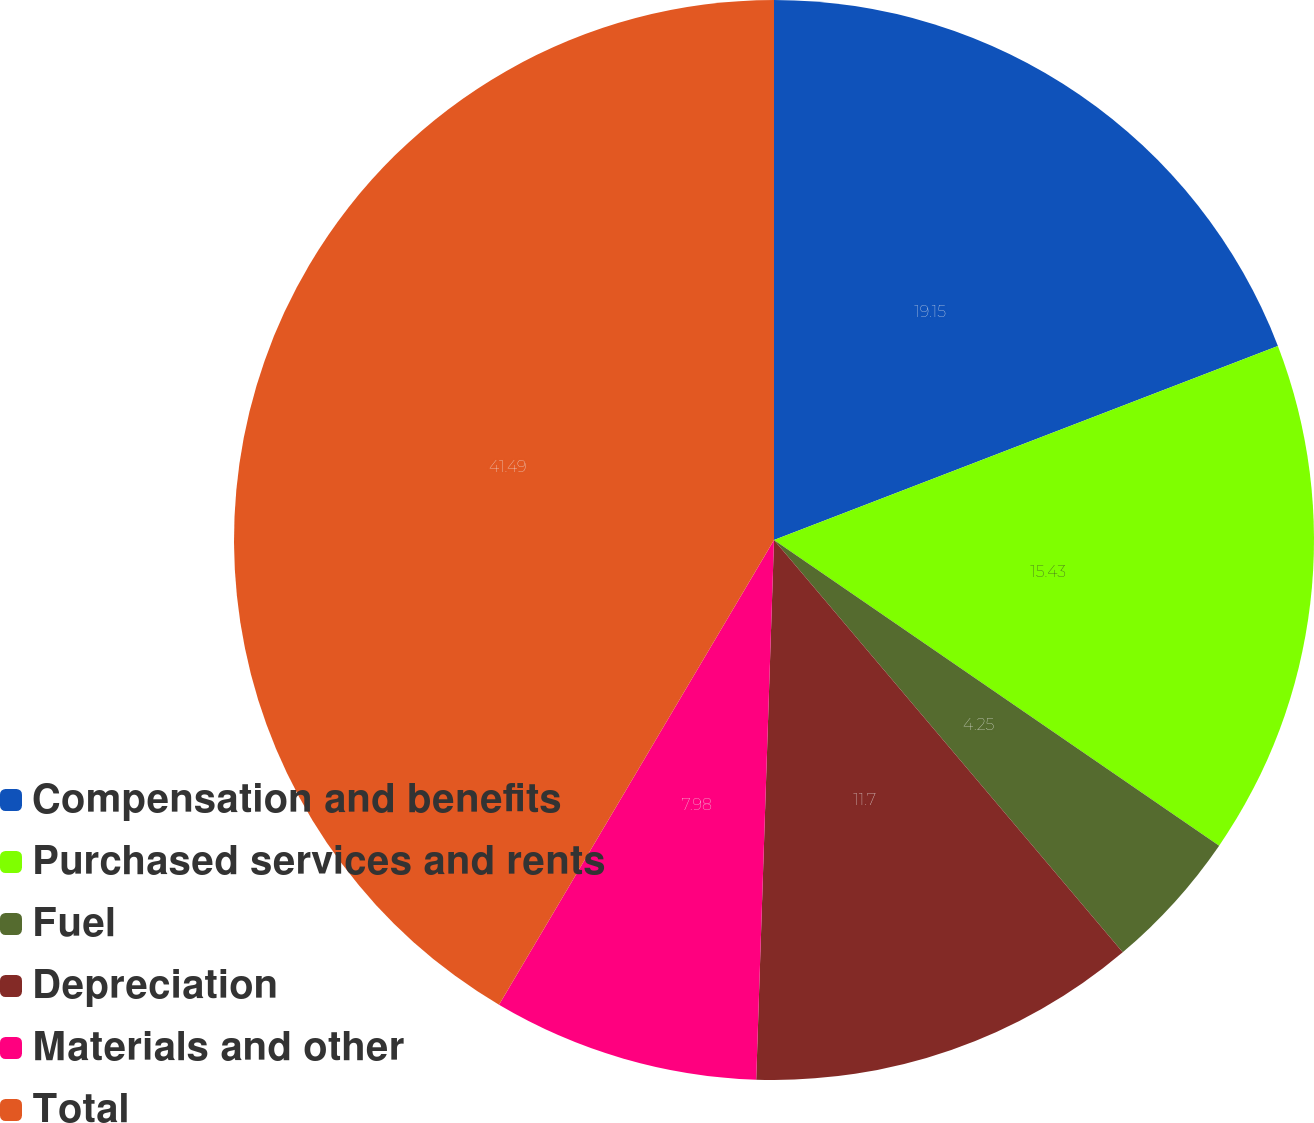Convert chart to OTSL. <chart><loc_0><loc_0><loc_500><loc_500><pie_chart><fcel>Compensation and benefits<fcel>Purchased services and rents<fcel>Fuel<fcel>Depreciation<fcel>Materials and other<fcel>Total<nl><fcel>19.15%<fcel>15.43%<fcel>4.25%<fcel>11.7%<fcel>7.98%<fcel>41.5%<nl></chart> 